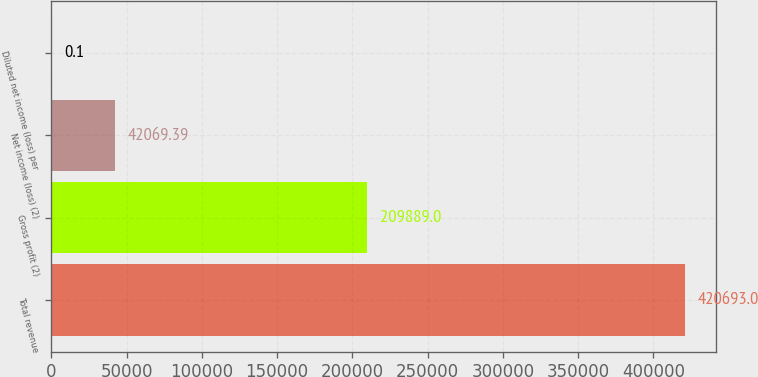Convert chart. <chart><loc_0><loc_0><loc_500><loc_500><bar_chart><fcel>Total revenue<fcel>Gross profit (2)<fcel>Net income (loss) (2)<fcel>Diluted net income (loss) per<nl><fcel>420693<fcel>209889<fcel>42069.4<fcel>0.1<nl></chart> 